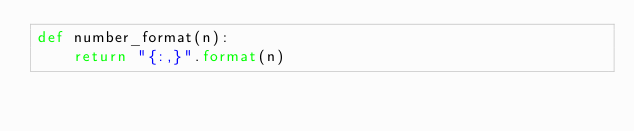Convert code to text. <code><loc_0><loc_0><loc_500><loc_500><_Python_>def number_format(n):
    return "{:,}".format(n)</code> 